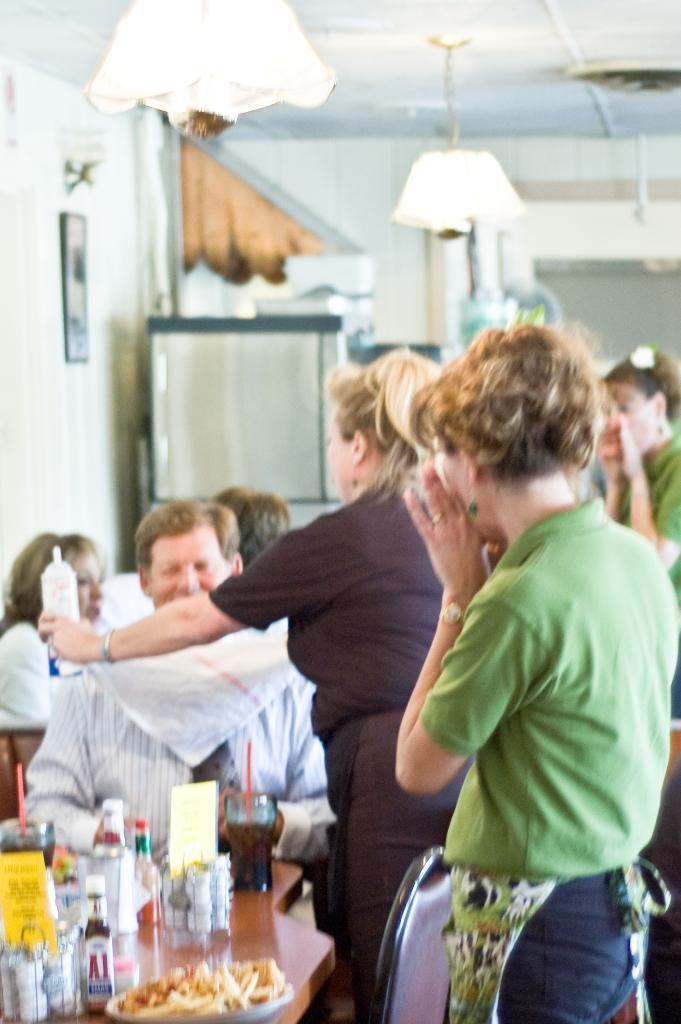In one or two sentences, can you explain what this image depicts? In this image there are two women who are standing on the right side on the left side there are group of people who are sitting on a chair on the bottom corner there is one table on the table there are some glasses and bottles and plates are there on the top there is ceiling on the ceiling there are some lights on the left side there is one wall on the wall there is one photo frame. 